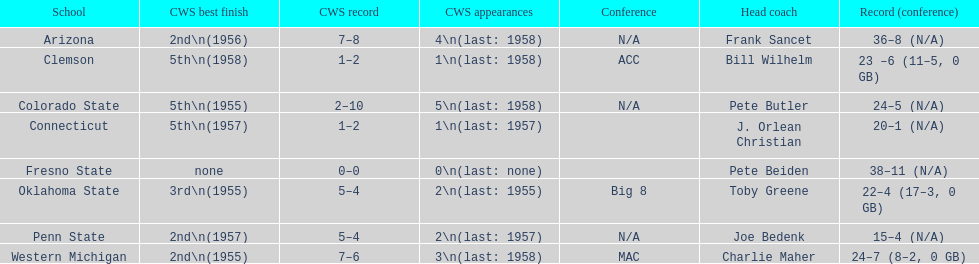What was the least amount of wins recorded by the losingest team? 15–4 (N/A). Which team held this record? Penn State. 